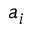Convert formula to latex. <formula><loc_0><loc_0><loc_500><loc_500>a _ { i }</formula> 